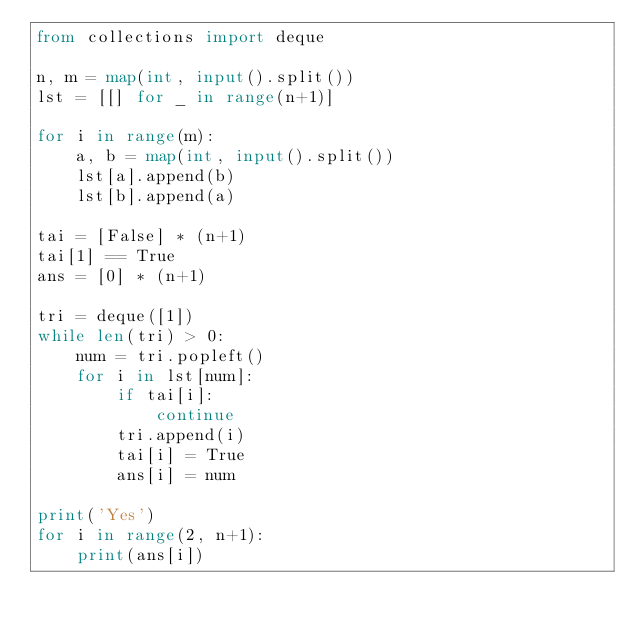<code> <loc_0><loc_0><loc_500><loc_500><_Python_>from collections import deque

n, m = map(int, input().split())
lst = [[] for _ in range(n+1)]

for i in range(m):
    a, b = map(int, input().split())
    lst[a].append(b)
    lst[b].append(a)

tai = [False] * (n+1)
tai[1] == True
ans = [0] * (n+1)

tri = deque([1])
while len(tri) > 0:
    num = tri.popleft()
    for i in lst[num]:
        if tai[i]:
            continue
        tri.append(i)
        tai[i] = True
        ans[i] = num

print('Yes')
for i in range(2, n+1):
    print(ans[i])</code> 